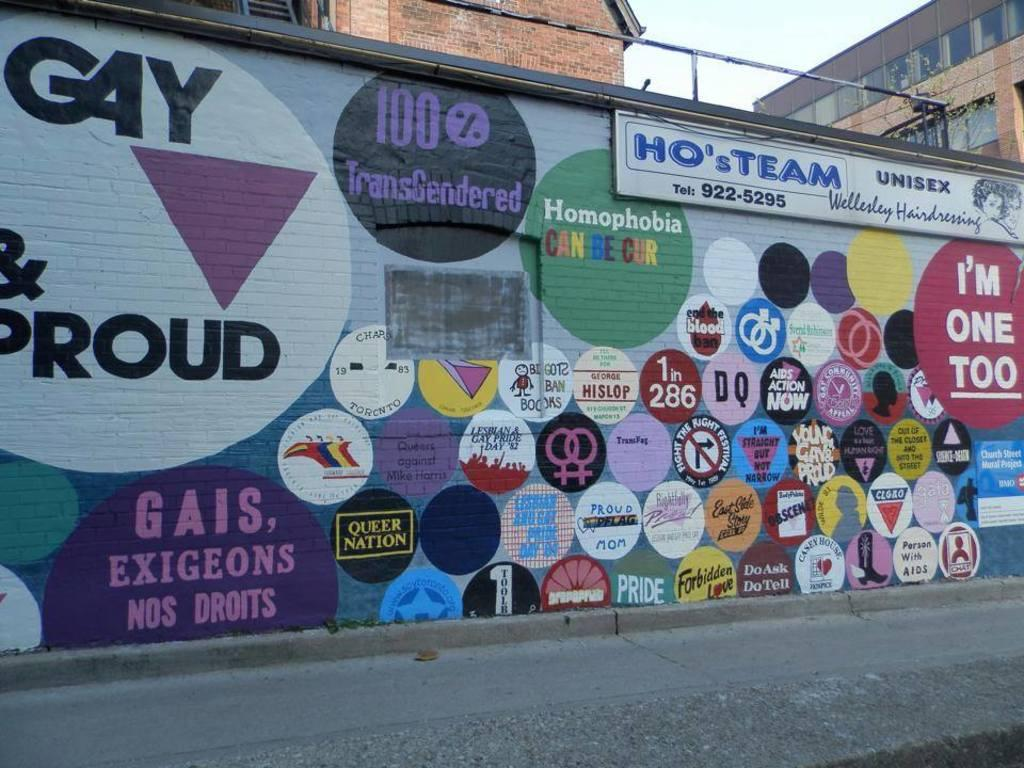<image>
Share a concise interpretation of the image provided. A painted wall on the side of a building that reads HO's TEAM. 